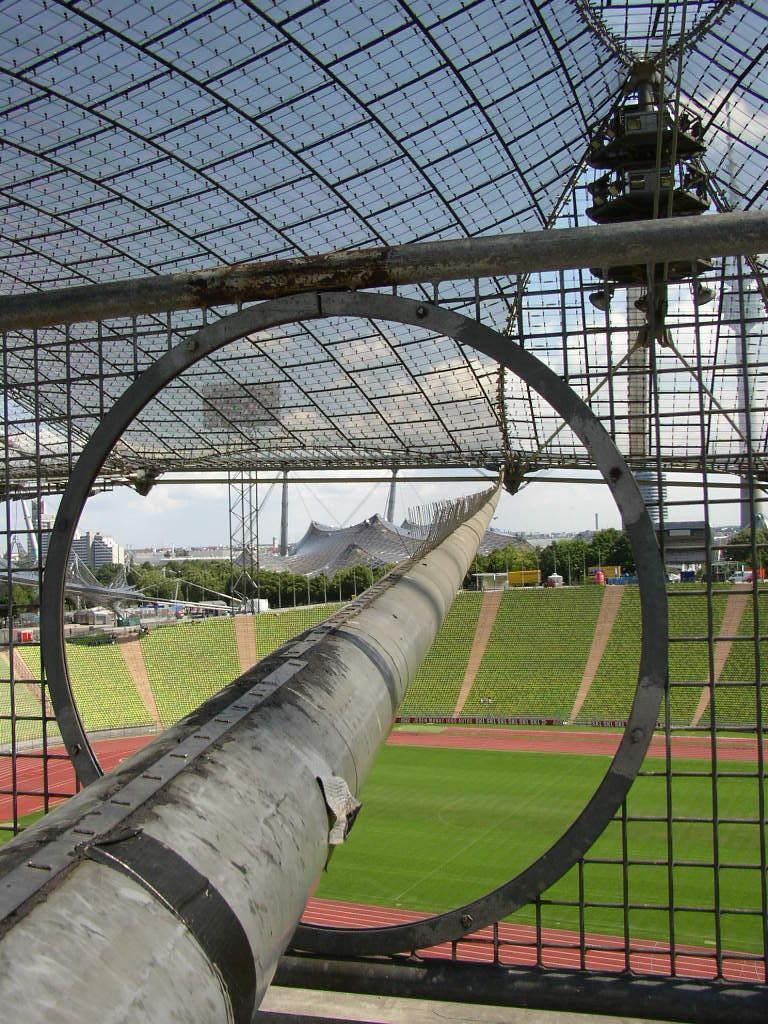Could you give a brief overview of what you see in this image? It is an iron net in the middle there is a ground. 